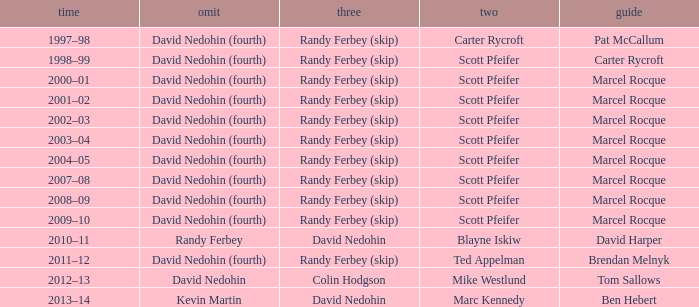Which Skip has a Season of 2002–03? David Nedohin (fourth). 